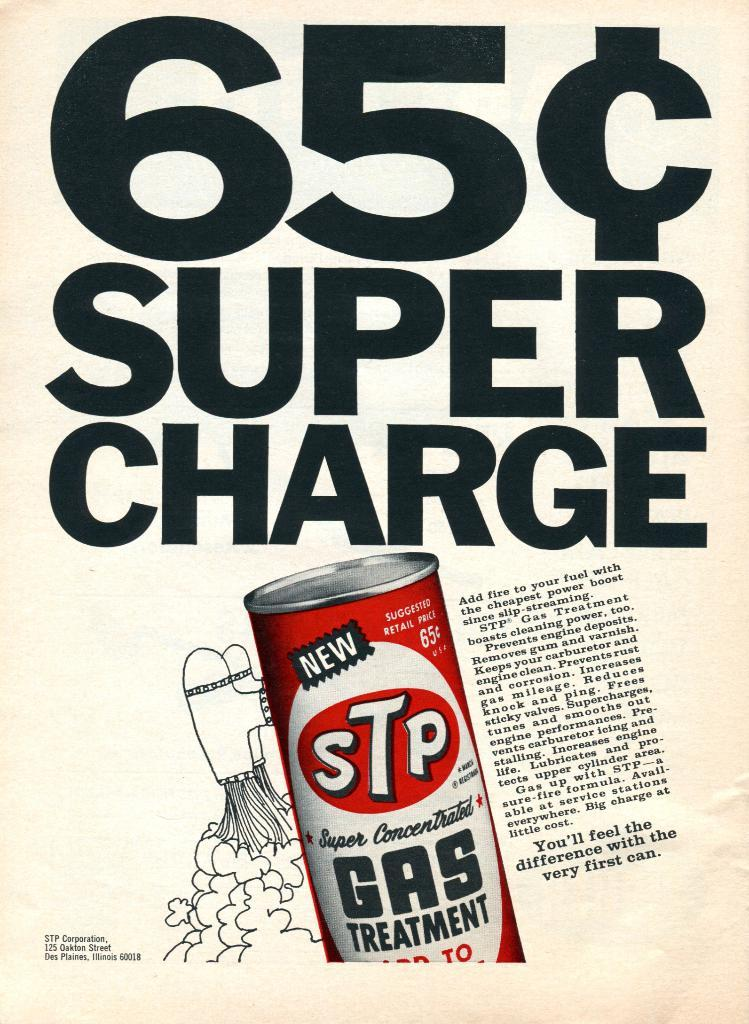<image>
Summarize the visual content of the image. STP is advertised at 65 cents for a can of it 